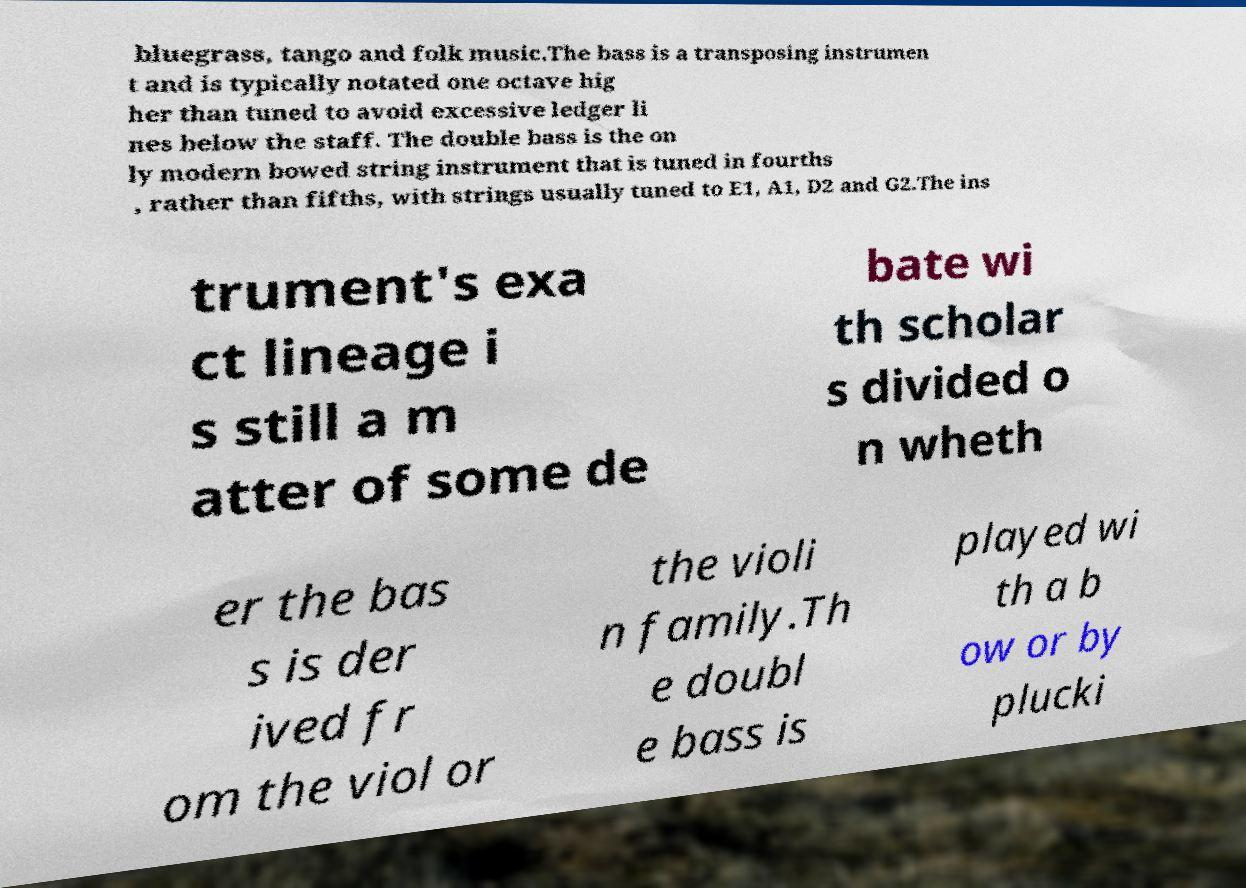Please identify and transcribe the text found in this image. bluegrass, tango and folk music.The bass is a transposing instrumen t and is typically notated one octave hig her than tuned to avoid excessive ledger li nes below the staff. The double bass is the on ly modern bowed string instrument that is tuned in fourths , rather than fifths, with strings usually tuned to E1, A1, D2 and G2.The ins trument's exa ct lineage i s still a m atter of some de bate wi th scholar s divided o n wheth er the bas s is der ived fr om the viol or the violi n family.Th e doubl e bass is played wi th a b ow or by plucki 